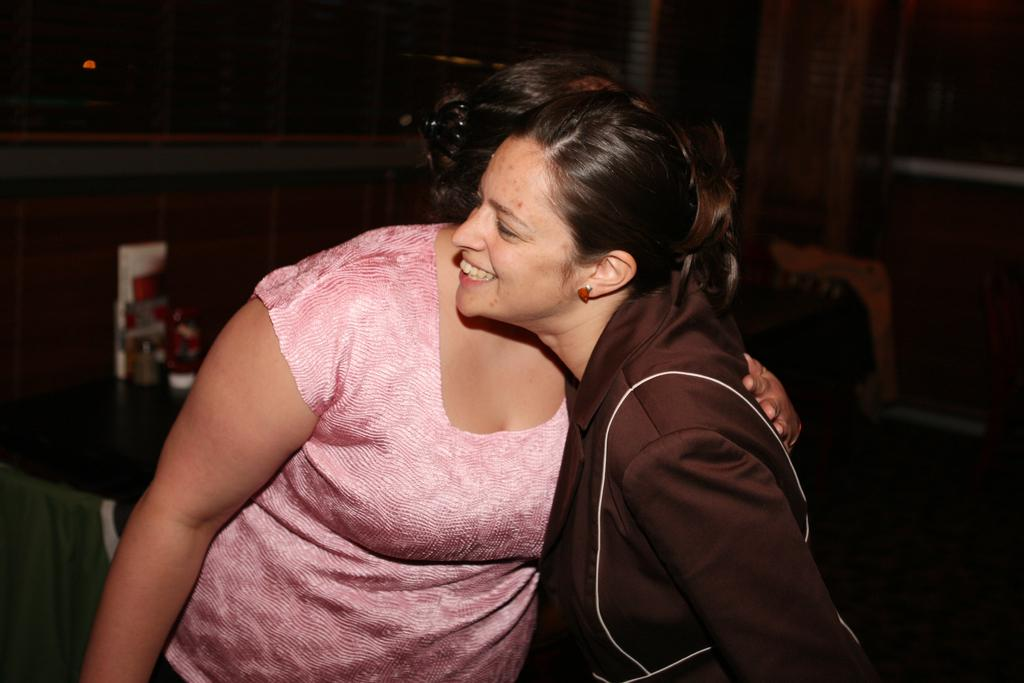How many people are in the image? There are two women in the image. What are the women doing in the image? The women are hugging each other. What can be seen in the background of the image? There is a wall in the background of the image. What type of lock can be seen on the wall in the image? There is no lock present on the wall in the image. 